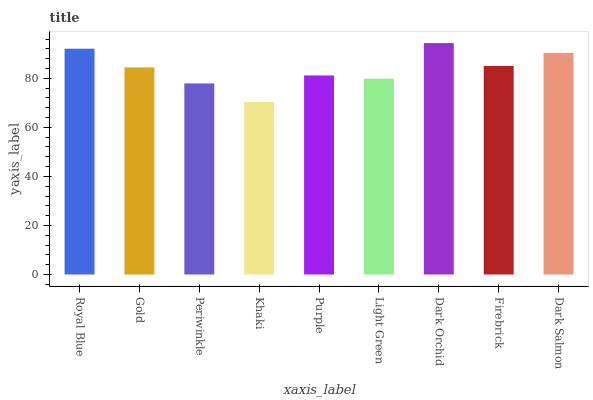Is Gold the minimum?
Answer yes or no. No. Is Gold the maximum?
Answer yes or no. No. Is Royal Blue greater than Gold?
Answer yes or no. Yes. Is Gold less than Royal Blue?
Answer yes or no. Yes. Is Gold greater than Royal Blue?
Answer yes or no. No. Is Royal Blue less than Gold?
Answer yes or no. No. Is Gold the high median?
Answer yes or no. Yes. Is Gold the low median?
Answer yes or no. Yes. Is Purple the high median?
Answer yes or no. No. Is Dark Orchid the low median?
Answer yes or no. No. 